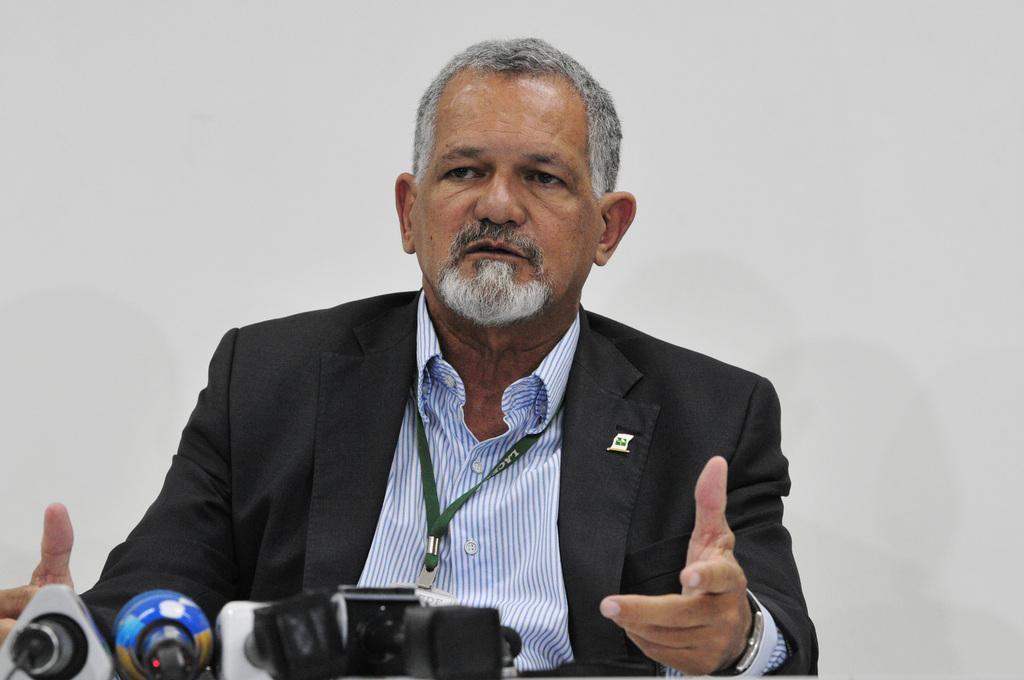Please provide a concise description of this image. In this image we can see one man in a suit sitting in front of the microphones, wearing an ID card and talking. There is the white background. 